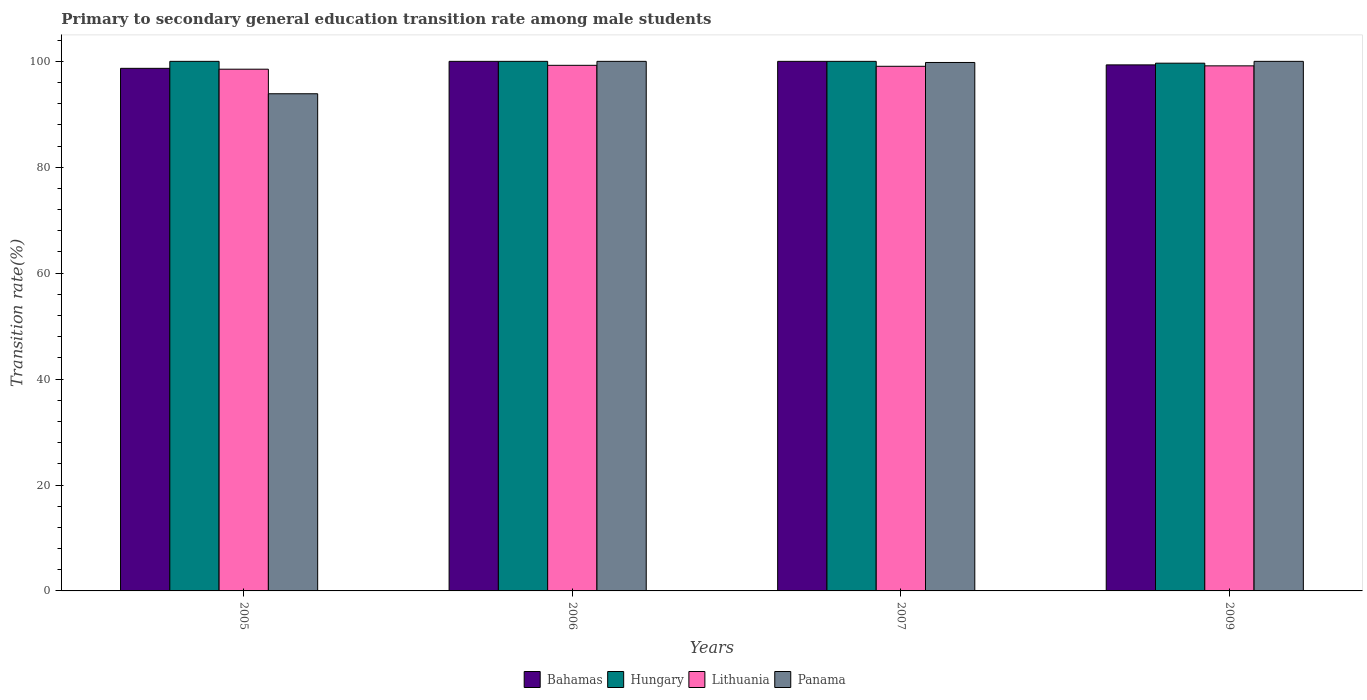How many different coloured bars are there?
Ensure brevity in your answer.  4. Are the number of bars per tick equal to the number of legend labels?
Offer a terse response. Yes. How many bars are there on the 3rd tick from the right?
Offer a terse response. 4. What is the label of the 4th group of bars from the left?
Offer a very short reply. 2009. What is the transition rate in Lithuania in 2007?
Keep it short and to the point. 99.07. Across all years, what is the maximum transition rate in Bahamas?
Offer a very short reply. 100. Across all years, what is the minimum transition rate in Panama?
Your answer should be very brief. 93.88. In which year was the transition rate in Hungary maximum?
Keep it short and to the point. 2005. What is the total transition rate in Hungary in the graph?
Provide a short and direct response. 399.65. What is the difference between the transition rate in Bahamas in 2005 and that in 2006?
Ensure brevity in your answer.  -1.32. What is the difference between the transition rate in Panama in 2005 and the transition rate in Hungary in 2006?
Give a very brief answer. -6.12. What is the average transition rate in Panama per year?
Offer a terse response. 98.42. In the year 2007, what is the difference between the transition rate in Lithuania and transition rate in Panama?
Ensure brevity in your answer.  -0.72. In how many years, is the transition rate in Bahamas greater than 12 %?
Keep it short and to the point. 4. What is the ratio of the transition rate in Bahamas in 2006 to that in 2007?
Your answer should be compact. 1. Is the transition rate in Bahamas in 2005 less than that in 2009?
Offer a terse response. Yes. Is the difference between the transition rate in Lithuania in 2006 and 2007 greater than the difference between the transition rate in Panama in 2006 and 2007?
Keep it short and to the point. No. What is the difference between the highest and the lowest transition rate in Bahamas?
Your response must be concise. 1.32. Is the sum of the transition rate in Bahamas in 2007 and 2009 greater than the maximum transition rate in Lithuania across all years?
Make the answer very short. Yes. What does the 1st bar from the left in 2009 represents?
Keep it short and to the point. Bahamas. What does the 2nd bar from the right in 2007 represents?
Provide a succinct answer. Lithuania. Is it the case that in every year, the sum of the transition rate in Bahamas and transition rate in Lithuania is greater than the transition rate in Hungary?
Offer a terse response. Yes. How many bars are there?
Your answer should be compact. 16. Are the values on the major ticks of Y-axis written in scientific E-notation?
Ensure brevity in your answer.  No. Does the graph contain grids?
Your response must be concise. No. Where does the legend appear in the graph?
Keep it short and to the point. Bottom center. How many legend labels are there?
Provide a short and direct response. 4. How are the legend labels stacked?
Your answer should be compact. Horizontal. What is the title of the graph?
Provide a short and direct response. Primary to secondary general education transition rate among male students. Does "Namibia" appear as one of the legend labels in the graph?
Keep it short and to the point. No. What is the label or title of the Y-axis?
Provide a succinct answer. Transition rate(%). What is the Transition rate(%) of Bahamas in 2005?
Offer a terse response. 98.68. What is the Transition rate(%) in Hungary in 2005?
Ensure brevity in your answer.  100. What is the Transition rate(%) in Lithuania in 2005?
Ensure brevity in your answer.  98.52. What is the Transition rate(%) in Panama in 2005?
Provide a short and direct response. 93.88. What is the Transition rate(%) of Bahamas in 2006?
Ensure brevity in your answer.  100. What is the Transition rate(%) in Hungary in 2006?
Give a very brief answer. 100. What is the Transition rate(%) of Lithuania in 2006?
Provide a succinct answer. 99.25. What is the Transition rate(%) in Bahamas in 2007?
Provide a short and direct response. 100. What is the Transition rate(%) of Lithuania in 2007?
Make the answer very short. 99.07. What is the Transition rate(%) in Panama in 2007?
Your answer should be compact. 99.79. What is the Transition rate(%) in Bahamas in 2009?
Your response must be concise. 99.33. What is the Transition rate(%) of Hungary in 2009?
Your answer should be compact. 99.65. What is the Transition rate(%) of Lithuania in 2009?
Give a very brief answer. 99.15. What is the Transition rate(%) in Panama in 2009?
Offer a very short reply. 100. Across all years, what is the maximum Transition rate(%) in Bahamas?
Keep it short and to the point. 100. Across all years, what is the maximum Transition rate(%) of Hungary?
Your response must be concise. 100. Across all years, what is the maximum Transition rate(%) in Lithuania?
Give a very brief answer. 99.25. Across all years, what is the minimum Transition rate(%) in Bahamas?
Offer a terse response. 98.68. Across all years, what is the minimum Transition rate(%) of Hungary?
Give a very brief answer. 99.65. Across all years, what is the minimum Transition rate(%) in Lithuania?
Give a very brief answer. 98.52. Across all years, what is the minimum Transition rate(%) of Panama?
Your answer should be compact. 93.88. What is the total Transition rate(%) of Bahamas in the graph?
Provide a succinct answer. 398.01. What is the total Transition rate(%) in Hungary in the graph?
Give a very brief answer. 399.65. What is the total Transition rate(%) of Lithuania in the graph?
Make the answer very short. 395.99. What is the total Transition rate(%) of Panama in the graph?
Give a very brief answer. 393.67. What is the difference between the Transition rate(%) in Bahamas in 2005 and that in 2006?
Your answer should be very brief. -1.32. What is the difference between the Transition rate(%) of Hungary in 2005 and that in 2006?
Give a very brief answer. 0. What is the difference between the Transition rate(%) in Lithuania in 2005 and that in 2006?
Give a very brief answer. -0.73. What is the difference between the Transition rate(%) in Panama in 2005 and that in 2006?
Your answer should be compact. -6.12. What is the difference between the Transition rate(%) in Bahamas in 2005 and that in 2007?
Make the answer very short. -1.32. What is the difference between the Transition rate(%) in Hungary in 2005 and that in 2007?
Give a very brief answer. 0. What is the difference between the Transition rate(%) in Lithuania in 2005 and that in 2007?
Your answer should be compact. -0.55. What is the difference between the Transition rate(%) in Panama in 2005 and that in 2007?
Your answer should be very brief. -5.91. What is the difference between the Transition rate(%) in Bahamas in 2005 and that in 2009?
Make the answer very short. -0.65. What is the difference between the Transition rate(%) in Hungary in 2005 and that in 2009?
Make the answer very short. 0.35. What is the difference between the Transition rate(%) in Lithuania in 2005 and that in 2009?
Offer a very short reply. -0.63. What is the difference between the Transition rate(%) in Panama in 2005 and that in 2009?
Offer a very short reply. -6.12. What is the difference between the Transition rate(%) of Hungary in 2006 and that in 2007?
Provide a succinct answer. 0. What is the difference between the Transition rate(%) in Lithuania in 2006 and that in 2007?
Make the answer very short. 0.18. What is the difference between the Transition rate(%) of Panama in 2006 and that in 2007?
Provide a succinct answer. 0.21. What is the difference between the Transition rate(%) of Bahamas in 2006 and that in 2009?
Provide a succinct answer. 0.67. What is the difference between the Transition rate(%) in Hungary in 2006 and that in 2009?
Give a very brief answer. 0.35. What is the difference between the Transition rate(%) of Lithuania in 2006 and that in 2009?
Ensure brevity in your answer.  0.1. What is the difference between the Transition rate(%) of Bahamas in 2007 and that in 2009?
Offer a terse response. 0.67. What is the difference between the Transition rate(%) of Hungary in 2007 and that in 2009?
Provide a succinct answer. 0.35. What is the difference between the Transition rate(%) in Lithuania in 2007 and that in 2009?
Ensure brevity in your answer.  -0.08. What is the difference between the Transition rate(%) of Panama in 2007 and that in 2009?
Your answer should be very brief. -0.21. What is the difference between the Transition rate(%) in Bahamas in 2005 and the Transition rate(%) in Hungary in 2006?
Offer a very short reply. -1.32. What is the difference between the Transition rate(%) in Bahamas in 2005 and the Transition rate(%) in Lithuania in 2006?
Ensure brevity in your answer.  -0.57. What is the difference between the Transition rate(%) of Bahamas in 2005 and the Transition rate(%) of Panama in 2006?
Make the answer very short. -1.32. What is the difference between the Transition rate(%) in Hungary in 2005 and the Transition rate(%) in Lithuania in 2006?
Keep it short and to the point. 0.75. What is the difference between the Transition rate(%) of Lithuania in 2005 and the Transition rate(%) of Panama in 2006?
Offer a terse response. -1.48. What is the difference between the Transition rate(%) in Bahamas in 2005 and the Transition rate(%) in Hungary in 2007?
Offer a very short reply. -1.32. What is the difference between the Transition rate(%) in Bahamas in 2005 and the Transition rate(%) in Lithuania in 2007?
Provide a short and direct response. -0.39. What is the difference between the Transition rate(%) in Bahamas in 2005 and the Transition rate(%) in Panama in 2007?
Your answer should be compact. -1.11. What is the difference between the Transition rate(%) of Hungary in 2005 and the Transition rate(%) of Lithuania in 2007?
Offer a very short reply. 0.93. What is the difference between the Transition rate(%) in Hungary in 2005 and the Transition rate(%) in Panama in 2007?
Keep it short and to the point. 0.21. What is the difference between the Transition rate(%) in Lithuania in 2005 and the Transition rate(%) in Panama in 2007?
Your answer should be very brief. -1.27. What is the difference between the Transition rate(%) in Bahamas in 2005 and the Transition rate(%) in Hungary in 2009?
Give a very brief answer. -0.97. What is the difference between the Transition rate(%) of Bahamas in 2005 and the Transition rate(%) of Lithuania in 2009?
Make the answer very short. -0.47. What is the difference between the Transition rate(%) in Bahamas in 2005 and the Transition rate(%) in Panama in 2009?
Your answer should be compact. -1.32. What is the difference between the Transition rate(%) of Hungary in 2005 and the Transition rate(%) of Lithuania in 2009?
Your response must be concise. 0.85. What is the difference between the Transition rate(%) of Lithuania in 2005 and the Transition rate(%) of Panama in 2009?
Provide a short and direct response. -1.48. What is the difference between the Transition rate(%) in Bahamas in 2006 and the Transition rate(%) in Lithuania in 2007?
Make the answer very short. 0.93. What is the difference between the Transition rate(%) in Bahamas in 2006 and the Transition rate(%) in Panama in 2007?
Keep it short and to the point. 0.21. What is the difference between the Transition rate(%) of Hungary in 2006 and the Transition rate(%) of Lithuania in 2007?
Offer a terse response. 0.93. What is the difference between the Transition rate(%) in Hungary in 2006 and the Transition rate(%) in Panama in 2007?
Your answer should be compact. 0.21. What is the difference between the Transition rate(%) of Lithuania in 2006 and the Transition rate(%) of Panama in 2007?
Ensure brevity in your answer.  -0.54. What is the difference between the Transition rate(%) in Bahamas in 2006 and the Transition rate(%) in Hungary in 2009?
Provide a short and direct response. 0.35. What is the difference between the Transition rate(%) in Bahamas in 2006 and the Transition rate(%) in Lithuania in 2009?
Provide a succinct answer. 0.85. What is the difference between the Transition rate(%) of Hungary in 2006 and the Transition rate(%) of Lithuania in 2009?
Provide a short and direct response. 0.85. What is the difference between the Transition rate(%) in Hungary in 2006 and the Transition rate(%) in Panama in 2009?
Offer a terse response. 0. What is the difference between the Transition rate(%) of Lithuania in 2006 and the Transition rate(%) of Panama in 2009?
Provide a succinct answer. -0.75. What is the difference between the Transition rate(%) in Bahamas in 2007 and the Transition rate(%) in Hungary in 2009?
Make the answer very short. 0.35. What is the difference between the Transition rate(%) of Bahamas in 2007 and the Transition rate(%) of Lithuania in 2009?
Your answer should be very brief. 0.85. What is the difference between the Transition rate(%) of Bahamas in 2007 and the Transition rate(%) of Panama in 2009?
Ensure brevity in your answer.  0. What is the difference between the Transition rate(%) of Hungary in 2007 and the Transition rate(%) of Lithuania in 2009?
Provide a succinct answer. 0.85. What is the difference between the Transition rate(%) in Lithuania in 2007 and the Transition rate(%) in Panama in 2009?
Ensure brevity in your answer.  -0.93. What is the average Transition rate(%) of Bahamas per year?
Provide a succinct answer. 99.5. What is the average Transition rate(%) of Hungary per year?
Make the answer very short. 99.91. What is the average Transition rate(%) of Lithuania per year?
Offer a terse response. 99. What is the average Transition rate(%) of Panama per year?
Your answer should be compact. 98.42. In the year 2005, what is the difference between the Transition rate(%) of Bahamas and Transition rate(%) of Hungary?
Keep it short and to the point. -1.32. In the year 2005, what is the difference between the Transition rate(%) in Bahamas and Transition rate(%) in Lithuania?
Make the answer very short. 0.16. In the year 2005, what is the difference between the Transition rate(%) in Bahamas and Transition rate(%) in Panama?
Make the answer very short. 4.8. In the year 2005, what is the difference between the Transition rate(%) of Hungary and Transition rate(%) of Lithuania?
Your answer should be very brief. 1.48. In the year 2005, what is the difference between the Transition rate(%) in Hungary and Transition rate(%) in Panama?
Your answer should be compact. 6.12. In the year 2005, what is the difference between the Transition rate(%) in Lithuania and Transition rate(%) in Panama?
Keep it short and to the point. 4.64. In the year 2006, what is the difference between the Transition rate(%) of Bahamas and Transition rate(%) of Hungary?
Offer a very short reply. 0. In the year 2006, what is the difference between the Transition rate(%) in Bahamas and Transition rate(%) in Lithuania?
Make the answer very short. 0.75. In the year 2006, what is the difference between the Transition rate(%) of Bahamas and Transition rate(%) of Panama?
Ensure brevity in your answer.  0. In the year 2006, what is the difference between the Transition rate(%) of Hungary and Transition rate(%) of Lithuania?
Offer a very short reply. 0.75. In the year 2006, what is the difference between the Transition rate(%) in Lithuania and Transition rate(%) in Panama?
Your answer should be compact. -0.75. In the year 2007, what is the difference between the Transition rate(%) in Bahamas and Transition rate(%) in Hungary?
Provide a short and direct response. 0. In the year 2007, what is the difference between the Transition rate(%) of Bahamas and Transition rate(%) of Lithuania?
Provide a short and direct response. 0.93. In the year 2007, what is the difference between the Transition rate(%) of Bahamas and Transition rate(%) of Panama?
Offer a very short reply. 0.21. In the year 2007, what is the difference between the Transition rate(%) in Hungary and Transition rate(%) in Lithuania?
Provide a succinct answer. 0.93. In the year 2007, what is the difference between the Transition rate(%) in Hungary and Transition rate(%) in Panama?
Your answer should be compact. 0.21. In the year 2007, what is the difference between the Transition rate(%) in Lithuania and Transition rate(%) in Panama?
Make the answer very short. -0.72. In the year 2009, what is the difference between the Transition rate(%) of Bahamas and Transition rate(%) of Hungary?
Provide a short and direct response. -0.32. In the year 2009, what is the difference between the Transition rate(%) of Bahamas and Transition rate(%) of Lithuania?
Provide a short and direct response. 0.18. In the year 2009, what is the difference between the Transition rate(%) of Bahamas and Transition rate(%) of Panama?
Ensure brevity in your answer.  -0.67. In the year 2009, what is the difference between the Transition rate(%) of Hungary and Transition rate(%) of Lithuania?
Offer a very short reply. 0.5. In the year 2009, what is the difference between the Transition rate(%) in Hungary and Transition rate(%) in Panama?
Offer a terse response. -0.35. In the year 2009, what is the difference between the Transition rate(%) of Lithuania and Transition rate(%) of Panama?
Your answer should be compact. -0.85. What is the ratio of the Transition rate(%) of Bahamas in 2005 to that in 2006?
Provide a short and direct response. 0.99. What is the ratio of the Transition rate(%) in Hungary in 2005 to that in 2006?
Offer a terse response. 1. What is the ratio of the Transition rate(%) of Lithuania in 2005 to that in 2006?
Offer a very short reply. 0.99. What is the ratio of the Transition rate(%) in Panama in 2005 to that in 2006?
Give a very brief answer. 0.94. What is the ratio of the Transition rate(%) of Lithuania in 2005 to that in 2007?
Give a very brief answer. 0.99. What is the ratio of the Transition rate(%) of Panama in 2005 to that in 2007?
Offer a very short reply. 0.94. What is the ratio of the Transition rate(%) in Panama in 2005 to that in 2009?
Offer a terse response. 0.94. What is the ratio of the Transition rate(%) of Hungary in 2006 to that in 2007?
Provide a succinct answer. 1. What is the ratio of the Transition rate(%) in Hungary in 2006 to that in 2009?
Keep it short and to the point. 1. What is the ratio of the Transition rate(%) of Bahamas in 2007 to that in 2009?
Offer a very short reply. 1.01. What is the ratio of the Transition rate(%) of Hungary in 2007 to that in 2009?
Offer a very short reply. 1. What is the ratio of the Transition rate(%) in Lithuania in 2007 to that in 2009?
Provide a short and direct response. 1. What is the ratio of the Transition rate(%) in Panama in 2007 to that in 2009?
Make the answer very short. 1. What is the difference between the highest and the second highest Transition rate(%) of Bahamas?
Give a very brief answer. 0. What is the difference between the highest and the second highest Transition rate(%) in Hungary?
Keep it short and to the point. 0. What is the difference between the highest and the second highest Transition rate(%) of Lithuania?
Your answer should be very brief. 0.1. What is the difference between the highest and the second highest Transition rate(%) of Panama?
Your answer should be compact. 0. What is the difference between the highest and the lowest Transition rate(%) in Bahamas?
Ensure brevity in your answer.  1.32. What is the difference between the highest and the lowest Transition rate(%) in Hungary?
Make the answer very short. 0.35. What is the difference between the highest and the lowest Transition rate(%) in Lithuania?
Make the answer very short. 0.73. What is the difference between the highest and the lowest Transition rate(%) in Panama?
Your answer should be compact. 6.12. 